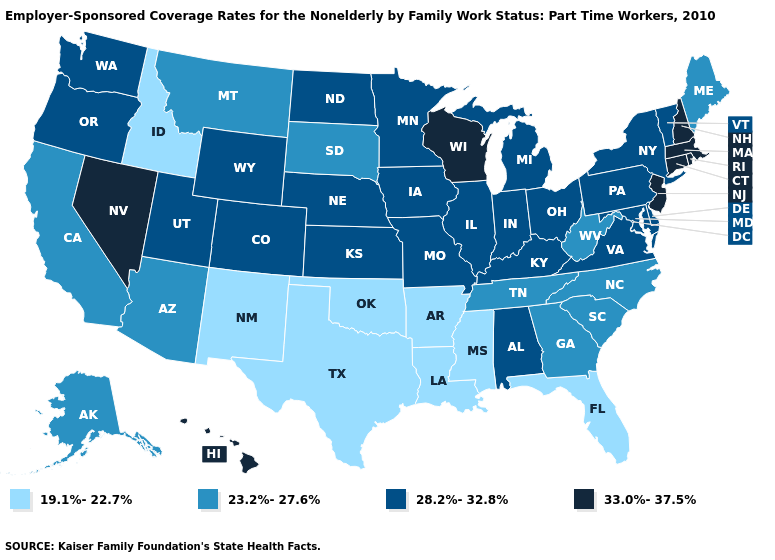Does Maryland have the same value as New York?
Be succinct. Yes. Does Texas have the lowest value in the USA?
Write a very short answer. Yes. Name the states that have a value in the range 33.0%-37.5%?
Quick response, please. Connecticut, Hawaii, Massachusetts, Nevada, New Hampshire, New Jersey, Rhode Island, Wisconsin. What is the value of Oklahoma?
Answer briefly. 19.1%-22.7%. Name the states that have a value in the range 23.2%-27.6%?
Be succinct. Alaska, Arizona, California, Georgia, Maine, Montana, North Carolina, South Carolina, South Dakota, Tennessee, West Virginia. Does Florida have a lower value than Arkansas?
Give a very brief answer. No. What is the value of Idaho?
Give a very brief answer. 19.1%-22.7%. Does the map have missing data?
Short answer required. No. What is the value of Wisconsin?
Keep it brief. 33.0%-37.5%. Name the states that have a value in the range 33.0%-37.5%?
Quick response, please. Connecticut, Hawaii, Massachusetts, Nevada, New Hampshire, New Jersey, Rhode Island, Wisconsin. Which states have the lowest value in the USA?
Keep it brief. Arkansas, Florida, Idaho, Louisiana, Mississippi, New Mexico, Oklahoma, Texas. Does Missouri have the highest value in the USA?
Concise answer only. No. Is the legend a continuous bar?
Write a very short answer. No. Does North Dakota have a lower value than Mississippi?
Quick response, please. No. Is the legend a continuous bar?
Be succinct. No. 